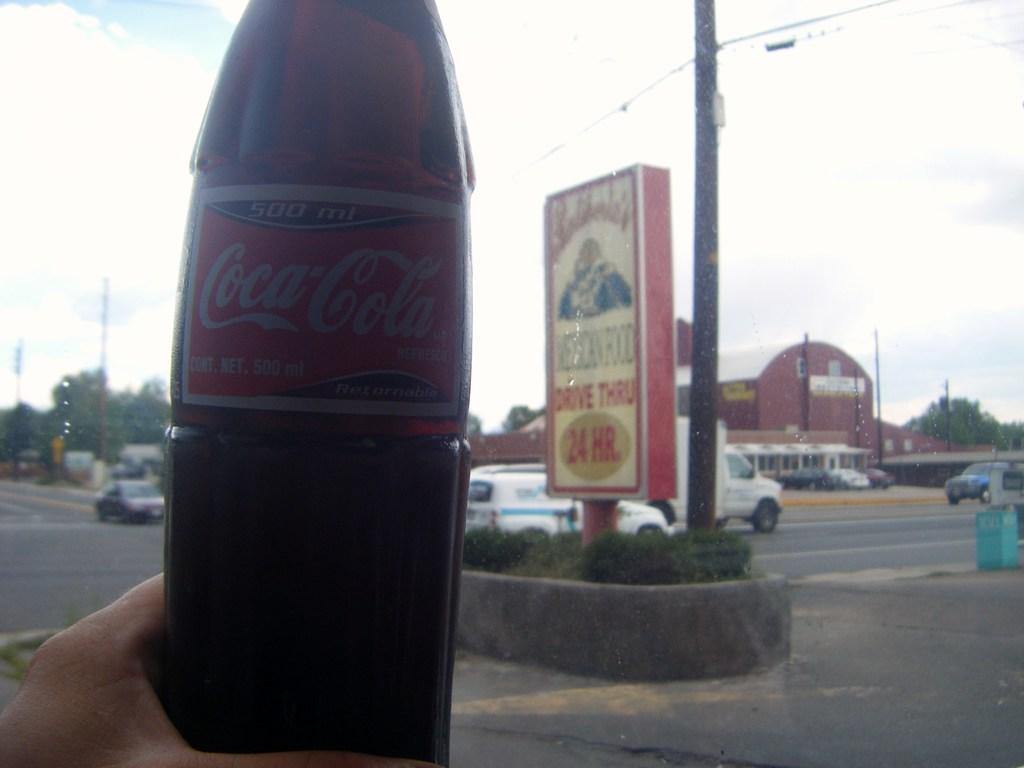<image>
Provide a brief description of the given image. Person holding a bottle of Coca COla in front of a sign. 